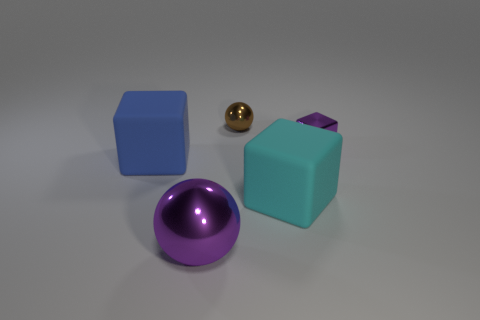There is a cyan cube; does it have the same size as the shiny sphere left of the brown shiny ball? yes 